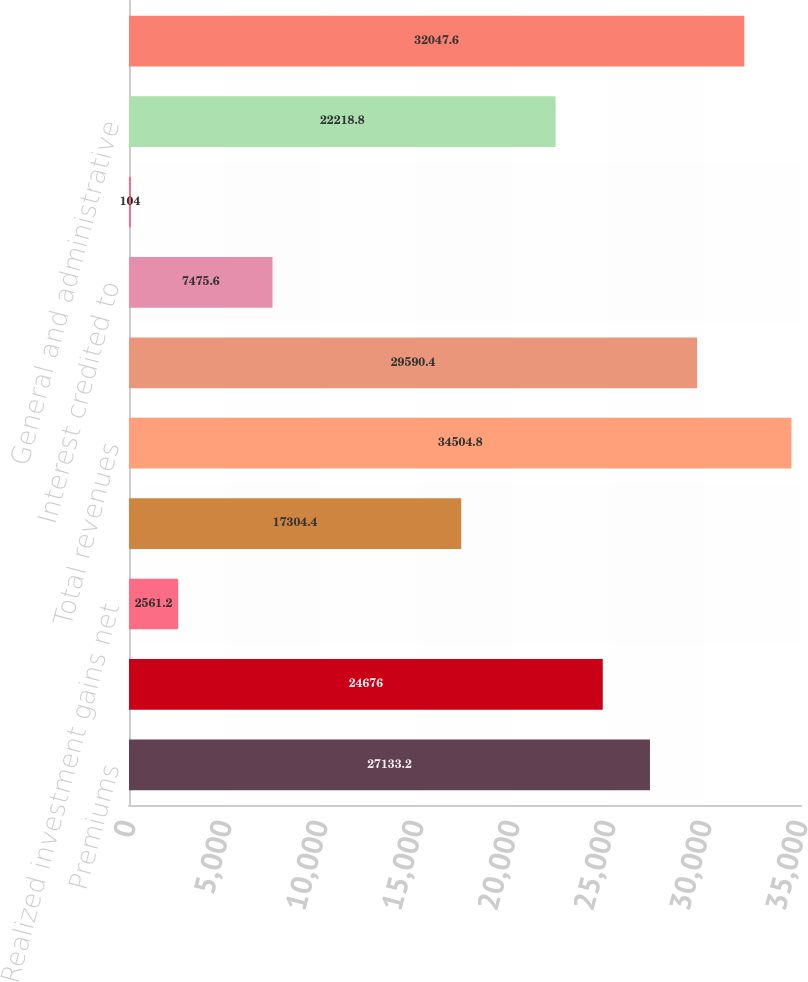Convert chart. <chart><loc_0><loc_0><loc_500><loc_500><bar_chart><fcel>Premiums<fcel>Net investment income<fcel>Realized investment gains net<fcel>Asset management fees and<fcel>Total revenues<fcel>Policyholders' benefits<fcel>Interest credited to<fcel>Dividends to policyholders<fcel>General and administrative<fcel>Total benefits and expenses<nl><fcel>27133.2<fcel>24676<fcel>2561.2<fcel>17304.4<fcel>34504.8<fcel>29590.4<fcel>7475.6<fcel>104<fcel>22218.8<fcel>32047.6<nl></chart> 